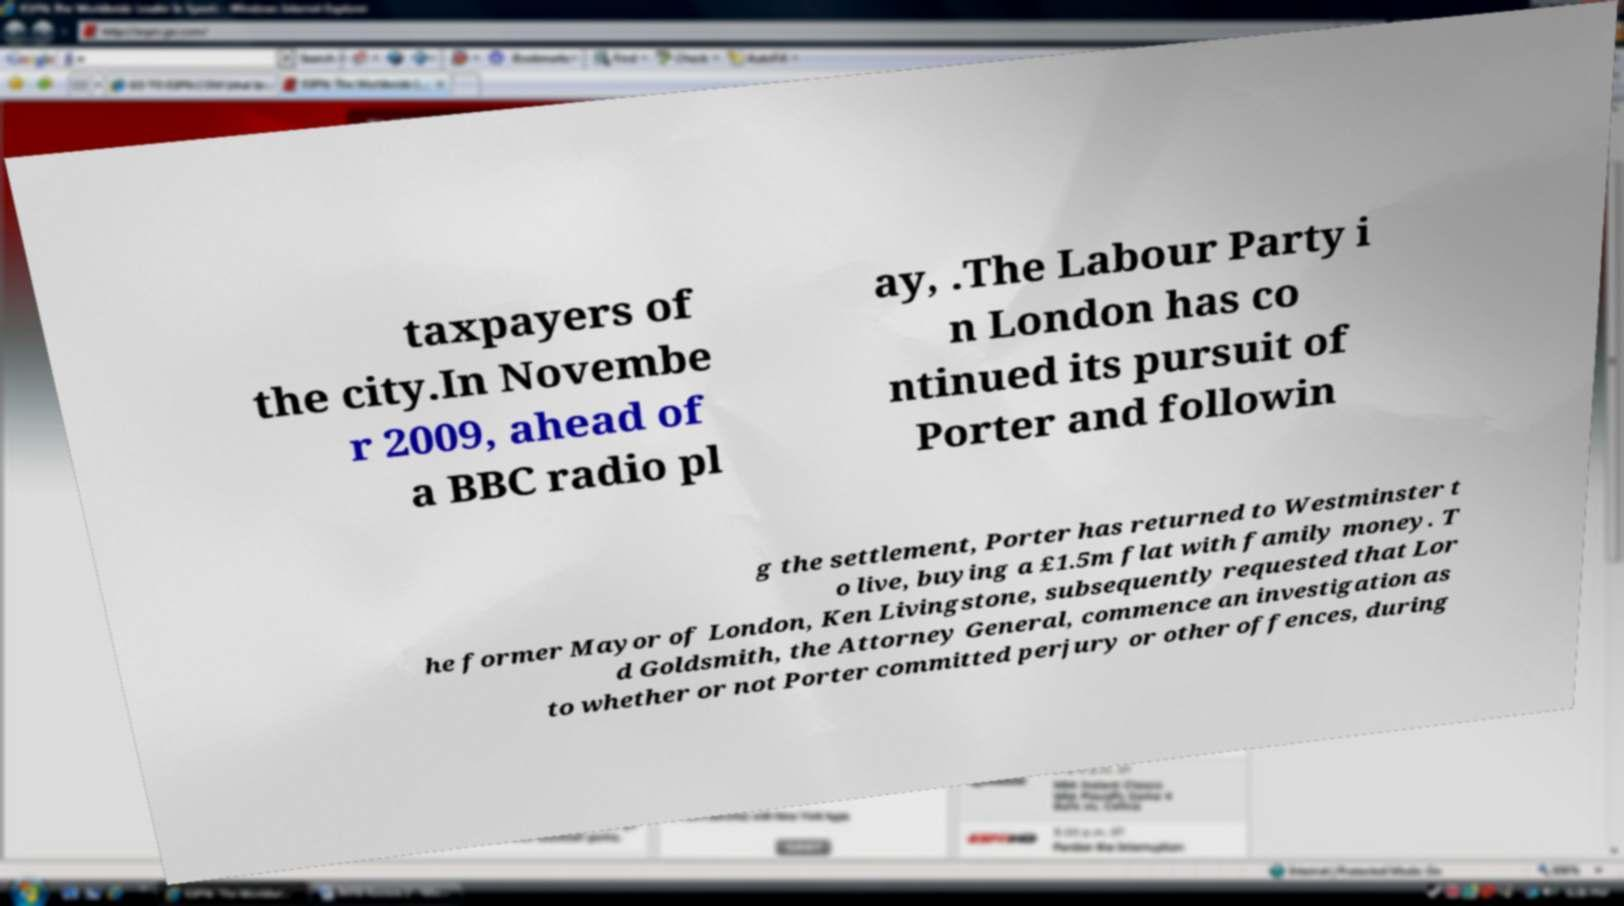What messages or text are displayed in this image? I need them in a readable, typed format. taxpayers of the city.In Novembe r 2009, ahead of a BBC radio pl ay, .The Labour Party i n London has co ntinued its pursuit of Porter and followin g the settlement, Porter has returned to Westminster t o live, buying a £1.5m flat with family money. T he former Mayor of London, Ken Livingstone, subsequently requested that Lor d Goldsmith, the Attorney General, commence an investigation as to whether or not Porter committed perjury or other offences, during 